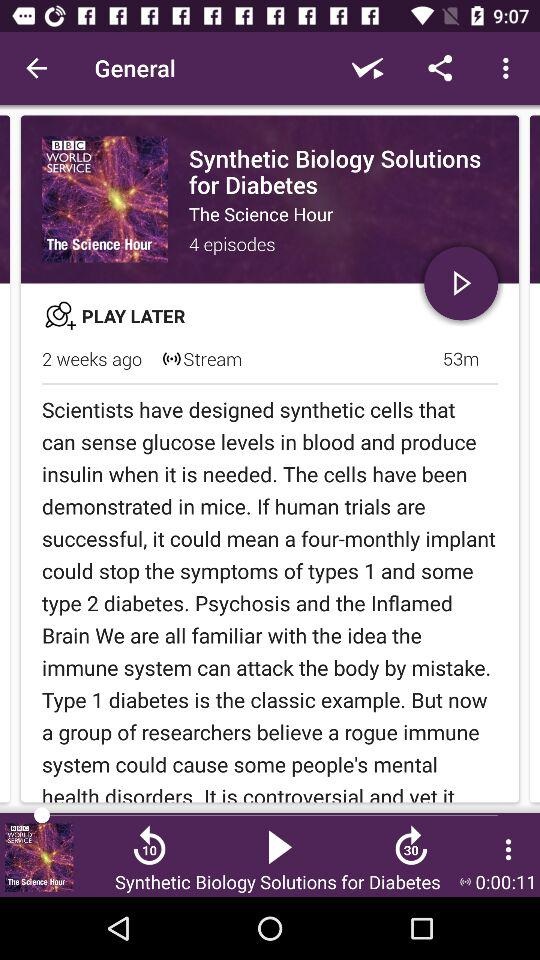What is the duration of the "Synthetic Biology Solutions" episode? The duration of the "Synthetic Biology Solutions" episode is 53 minutes. 